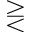<formula> <loc_0><loc_0><loc_500><loc_500>> r e q l e s s</formula> 